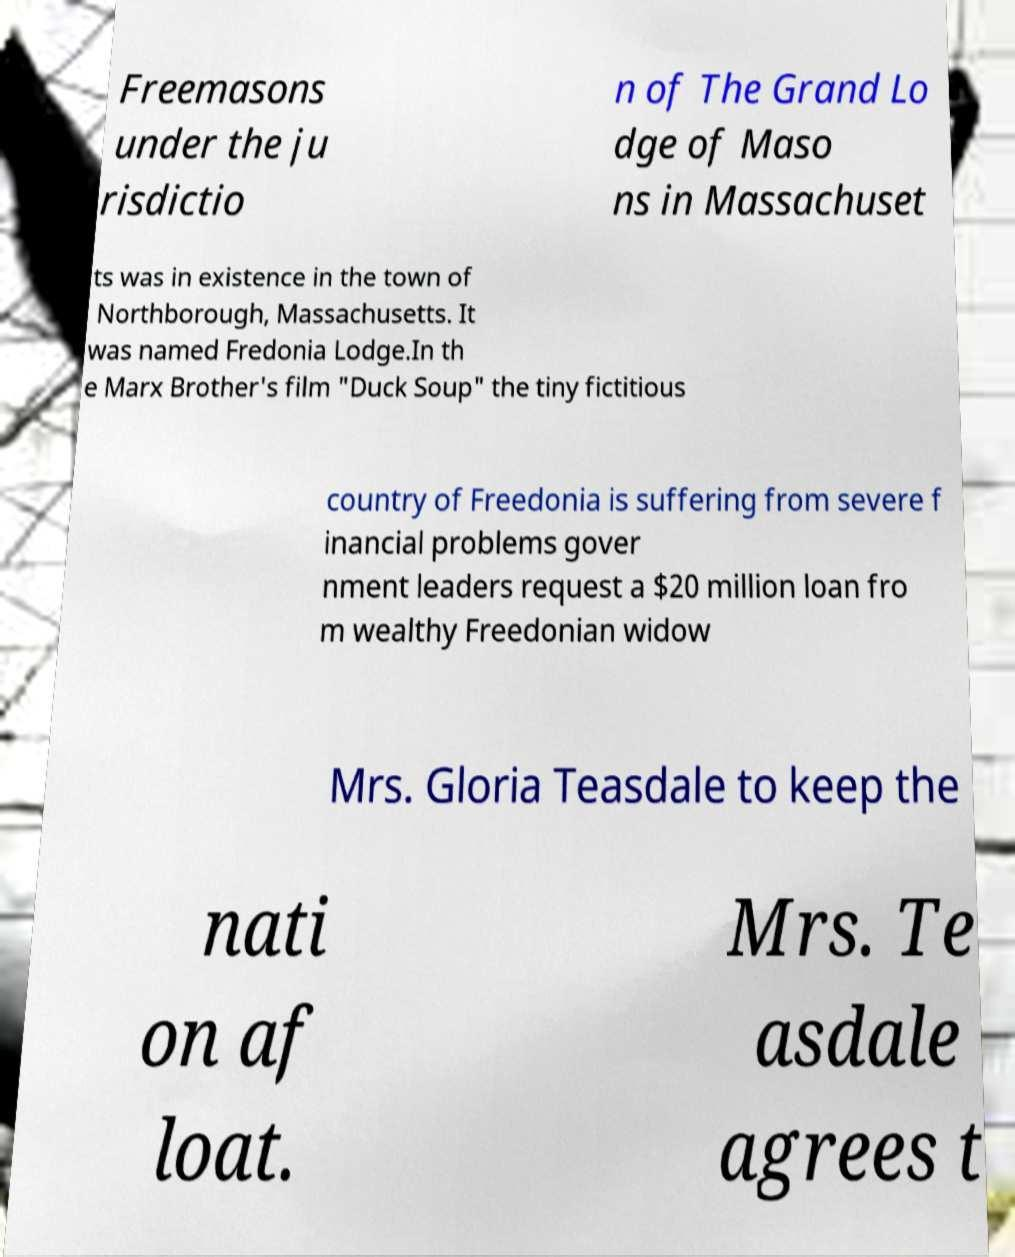Please read and relay the text visible in this image. What does it say? Freemasons under the ju risdictio n of The Grand Lo dge of Maso ns in Massachuset ts was in existence in the town of Northborough, Massachusetts. It was named Fredonia Lodge.In th e Marx Brother's film "Duck Soup" the tiny fictitious country of Freedonia is suffering from severe f inancial problems gover nment leaders request a $20 million loan fro m wealthy Freedonian widow Mrs. Gloria Teasdale to keep the nati on af loat. Mrs. Te asdale agrees t 